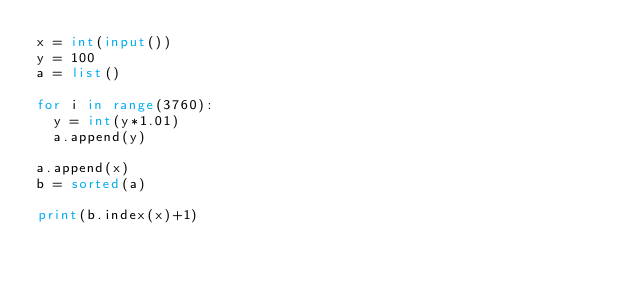<code> <loc_0><loc_0><loc_500><loc_500><_Python_>x = int(input())
y = 100
a = list()

for i in range(3760):
  y = int(y*1.01)
  a.append(y)

a.append(x)
b = sorted(a)

print(b.index(x)+1)</code> 